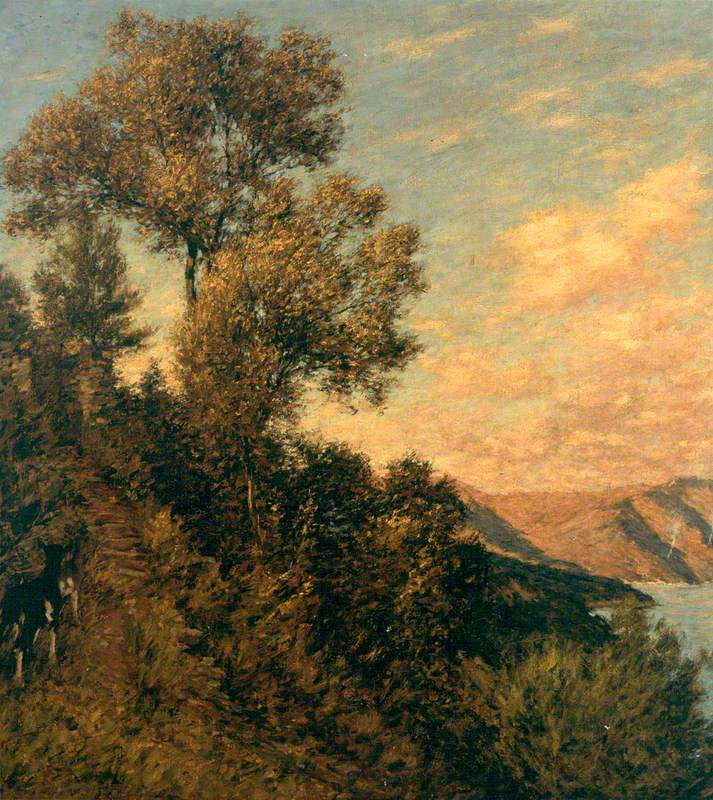What is this photo about? The painting captures an evocative landscape scene, rendered in the impressionist style, which is notable for its vivid use of color and dynamic brushstrokes that convey movement. In this painting, a lush tree stands prominently on a cliff, overlooking a serene body of water. The atmospheric conditions suggested by the color transitions in the sky and the reflections on the water seem to indicate either early morning or late evening light, likely depicting the quiet moments at either dawn or dusk. This artwork brilliantly explores the interplay of light and nature, characteristic of many 19th-century landscape paintings, inviting the viewer to contemplate the tranquil harmony of natural scenery. 